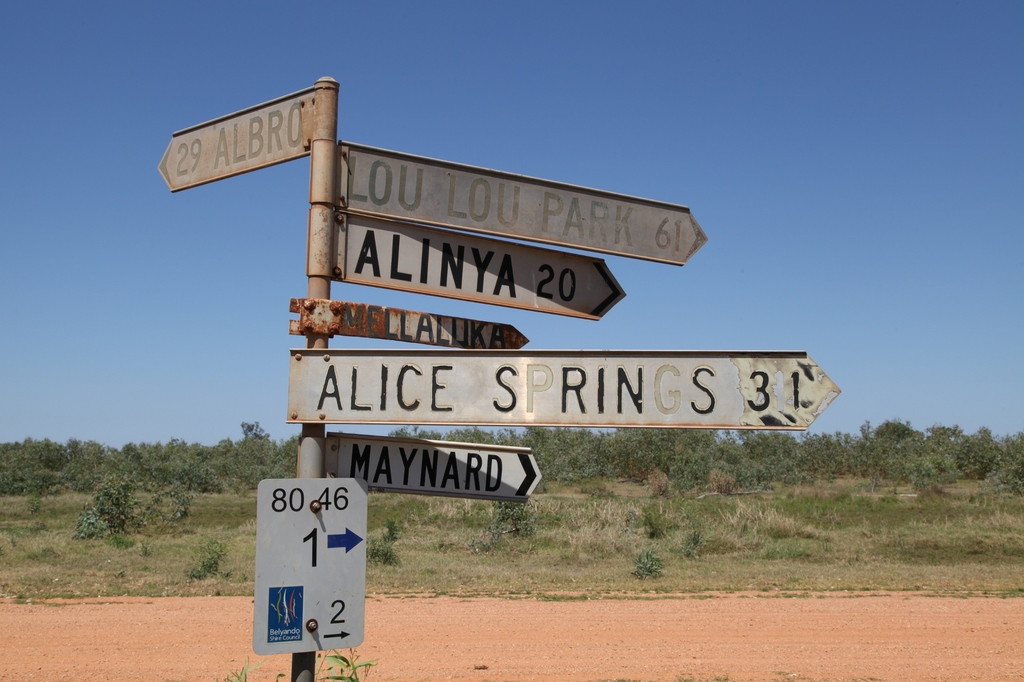Can you tell me more about the location and significance of Alice Springs mentioned on the signpost? Alice Springs is a pivotal town in Australia's Northern Territory, located roughly at the country's geographical center. Often seen as the gateway to exploring the central Australian desert, its remote location makes it a critical hub for supplies and tourism. The town is also culturally significant, offering a rich blend of Aboriginal heritage and modern Australian culture, making it a unique place where traditional and contemporary life intertwines. The distance marker '31' to Alice Springs on the signpost highlights its proximity, serving as a crucial navigation point in the outback. 